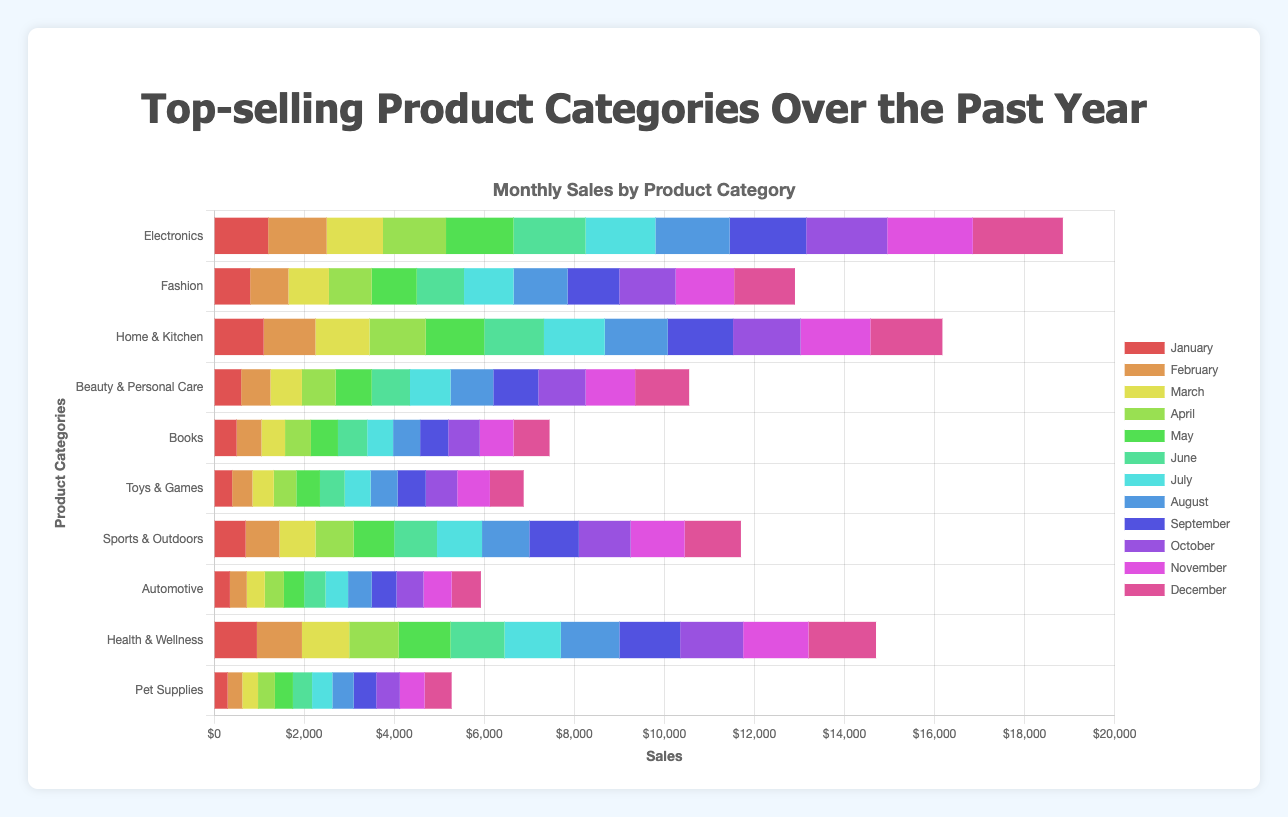Which product category had the highest sales in December? Look for the longest bar in the "December" column for each category. "Electronics" has the highest value (2000) in December.
Answer: Electronics Which two categories show a significant increase in sales from January to December? Compare the January and December sales for each category. "Electronics" rose from 1200 to 2000, and "Fashion" rose from 800 to 1350.
Answer: Electronics, Fashion What is the total sales value for Home & Kitchen in the second quarter (April to June)? Sum the sales from April, May, and June for "Home & Kitchen": 1250 (April) + 1300 (May) + 1325 (June) = 3875.
Answer: 3875 Which category had the least sales in June? Look for the shortest bar in the "June" column for each category. "Pet Supplies" has the lowest sales (425) in June.
Answer: Pet Supplies What is the average monthly sales for Beauty & Personal Care? Sum the sales for all months and divide by 12. (600 + 650 + 700 + 750 + 800 + 850 + 900 + 950 + 1000 + 1050 + 1100 + 1200) / 12 = 875.
Answer: 875 Which month has the highest total sales across all categories? Sum the sales for each month separately. Compare the sums to find the highest. November has the highest sum: 1900+1300+1550+1200+800+750+1250+650+1500+600 = 11500.
Answer: November How much did sales for Health & Wellness increase from January to July? Subtract the January sales from the July sales for Health & Wellness: 1250 (July) - 950 (January) = 300.
Answer: 300 Which category saw the most consistent sales growth month-over-month? Examine the sales data for steady increases each month. "Electronics" shows steady growth without declines.
Answer: Electronics What month had the highest sales for Sports & Outdoors? Look for the month with the highest value in the "Sports & Outdoors" row. December has the highest sales (1250) for Sports & Outdoors.
Answer: December How do the total sales of Electronics and Fashion compare in August? Compare the sales values for both categories in August. Electronics has 1650, and Fashion has 1200. Electronics' sales are higher.
Answer: Electronics 